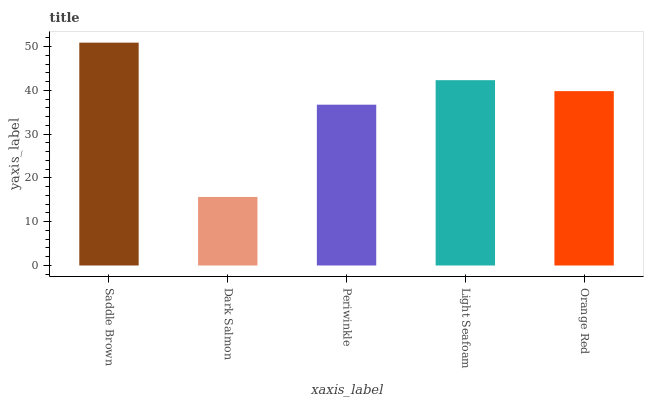Is Dark Salmon the minimum?
Answer yes or no. Yes. Is Saddle Brown the maximum?
Answer yes or no. Yes. Is Periwinkle the minimum?
Answer yes or no. No. Is Periwinkle the maximum?
Answer yes or no. No. Is Periwinkle greater than Dark Salmon?
Answer yes or no. Yes. Is Dark Salmon less than Periwinkle?
Answer yes or no. Yes. Is Dark Salmon greater than Periwinkle?
Answer yes or no. No. Is Periwinkle less than Dark Salmon?
Answer yes or no. No. Is Orange Red the high median?
Answer yes or no. Yes. Is Orange Red the low median?
Answer yes or no. Yes. Is Saddle Brown the high median?
Answer yes or no. No. Is Saddle Brown the low median?
Answer yes or no. No. 